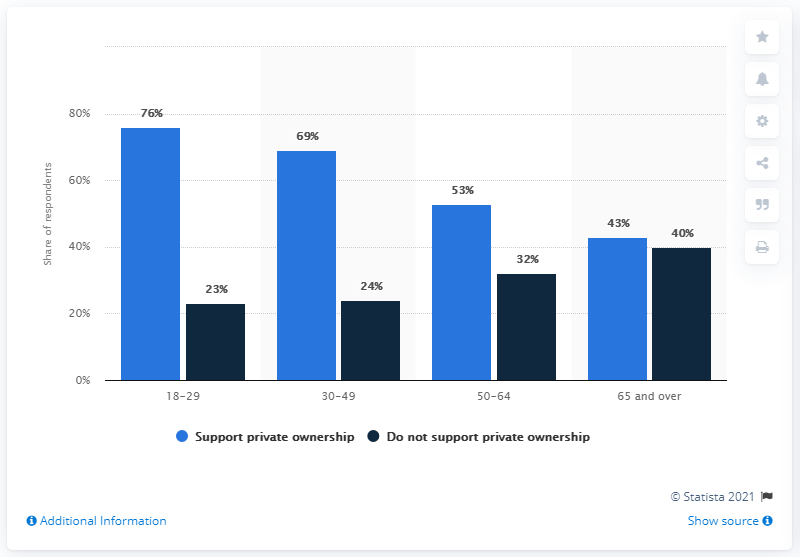List a handful of essential elements in this visual. According to the survey, 69% of respondents in the 30-49 age group support private ownership. The age group with the greatest discrepancy between the light blue and dark blue bars is 18-29 year olds. 